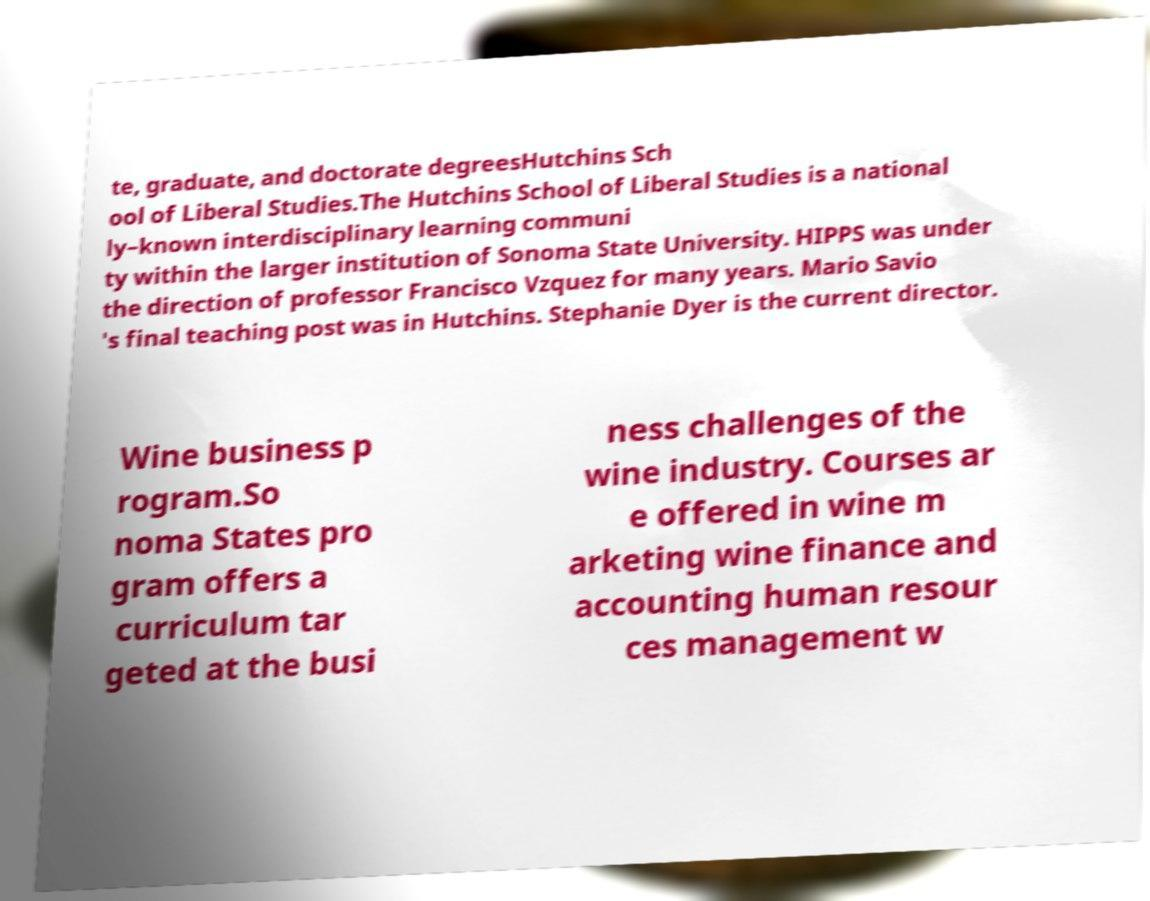Can you read and provide the text displayed in the image?This photo seems to have some interesting text. Can you extract and type it out for me? te, graduate, and doctorate degreesHutchins Sch ool of Liberal Studies.The Hutchins School of Liberal Studies is a national ly–known interdisciplinary learning communi ty within the larger institution of Sonoma State University. HIPPS was under the direction of professor Francisco Vzquez for many years. Mario Savio 's final teaching post was in Hutchins. Stephanie Dyer is the current director. Wine business p rogram.So noma States pro gram offers a curriculum tar geted at the busi ness challenges of the wine industry. Courses ar e offered in wine m arketing wine finance and accounting human resour ces management w 